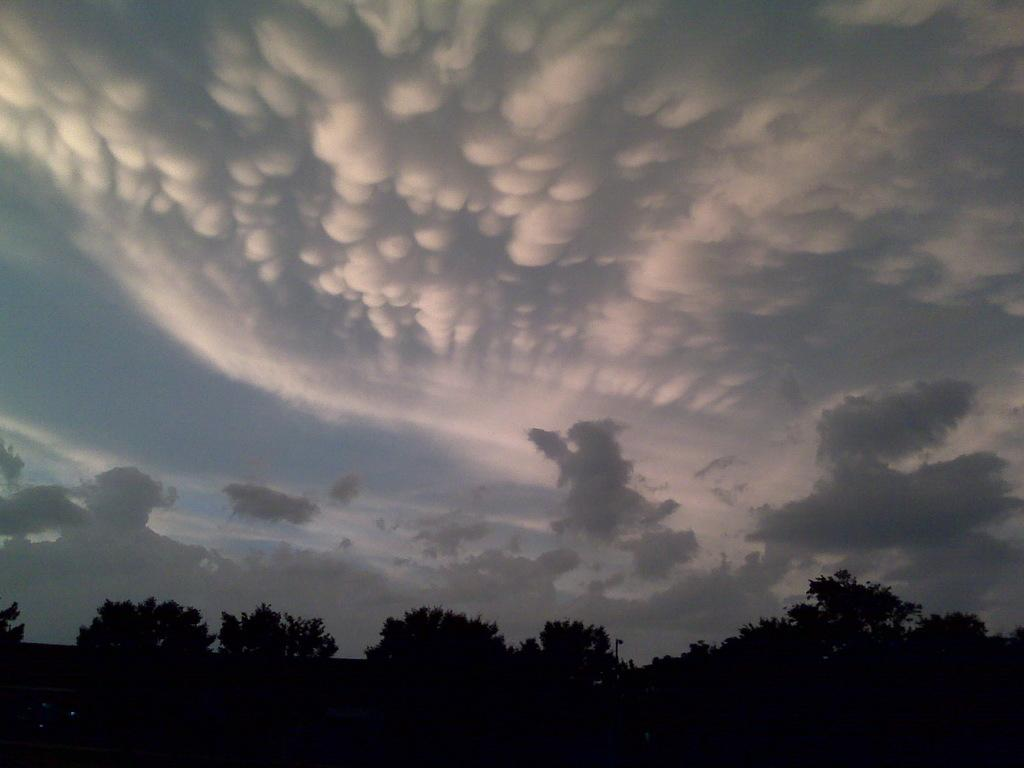What type of vegetation can be seen in the image? There are trees in the image. What can be seen in the sky in the image? There are clouds in the sky. How many gallons of milk can be seen in the image? There is no milk present in the image. What type of furniture can be seen in the image? There is no furniture present in the image. 